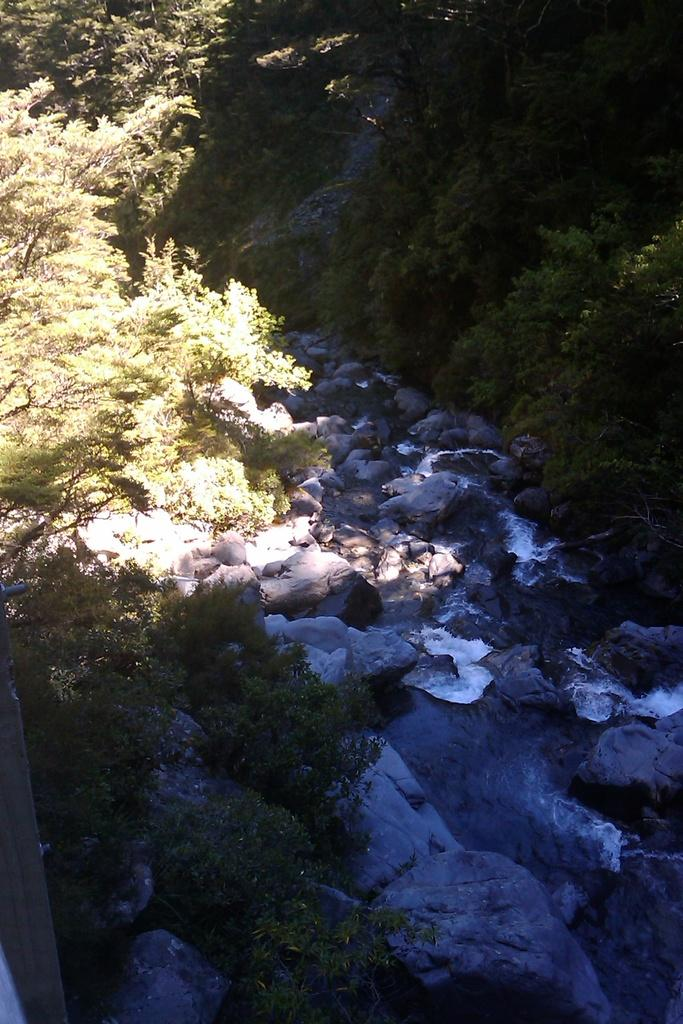What type of natural elements can be seen in the image? There are trees and rocks visible in the image. What else can be seen in the image besides trees and rocks? There is water visible in the image. What color is the sweater worn by the animal in the image? There is no sweater or animal present in the image. What type of voice can be heard coming from the trees in the image? There is no sound or voice present in the image. 